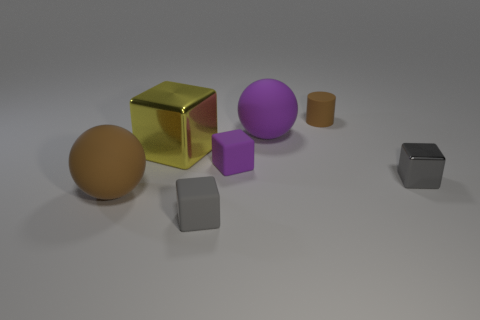What material is the big ball to the right of the big brown thing?
Your answer should be very brief. Rubber. There is a tiny gray cube on the right side of the tiny brown object; are there any brown things that are on the right side of it?
Offer a very short reply. No. What number of small cyan shiny blocks are there?
Ensure brevity in your answer.  0. Does the small shiny object have the same color as the cube that is in front of the large brown ball?
Give a very brief answer. Yes. Are there more yellow cubes than small blocks?
Provide a succinct answer. No. Is there anything else that has the same color as the tiny metallic thing?
Your answer should be compact. Yes. How many other objects are the same size as the purple rubber cube?
Give a very brief answer. 3. There is a brown thing that is on the left side of the tiny gray thing in front of the brown object in front of the small cylinder; what is it made of?
Your answer should be compact. Rubber. Is the cylinder made of the same material as the brown object that is on the left side of the tiny brown matte cylinder?
Offer a terse response. Yes. Is the number of tiny gray shiny cubes to the left of the yellow thing less than the number of purple objects to the left of the large purple sphere?
Give a very brief answer. Yes. 